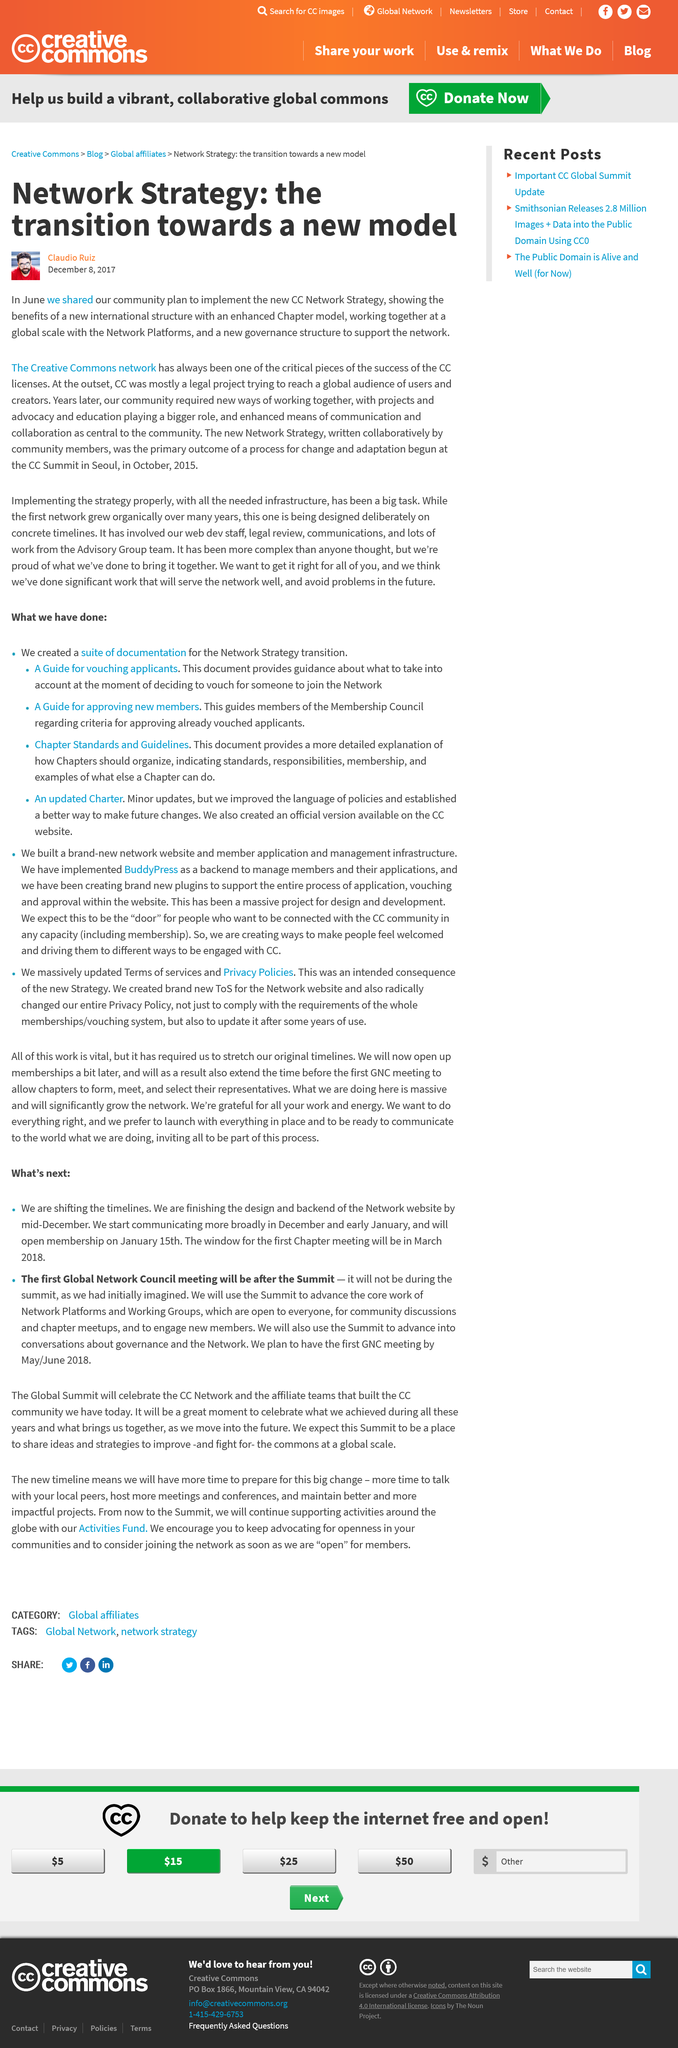Draw attention to some important aspects in this diagram. In June, the CC shared a community plan to implement the new CC Network Strategy. I, [your name], declare that the writing of the new Network Strategy began in 2015. The Creative Commons network is a success, as it has achieved widespread recognition and adoption for its open access licenses and has facilitated the sharing and reuse of creative works by individuals and organizations around the world. 